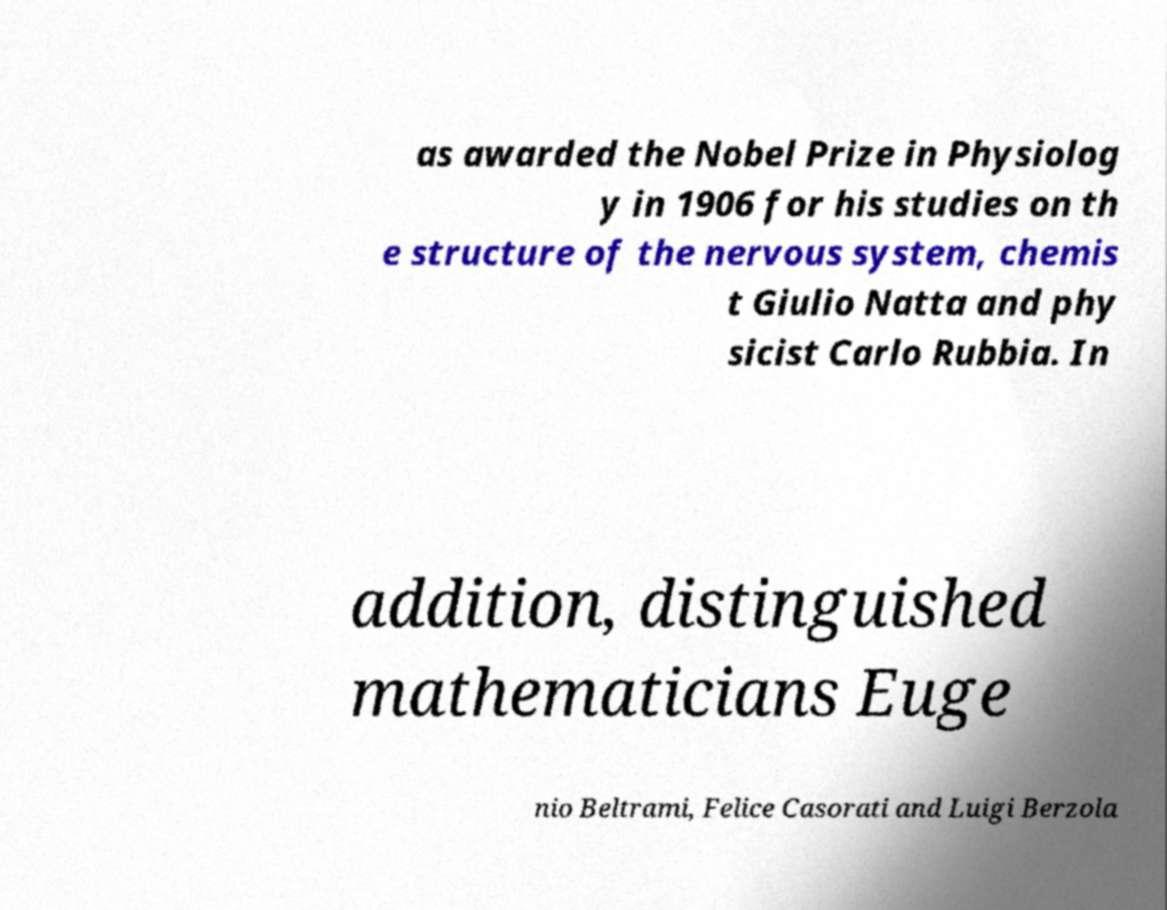Can you read and provide the text displayed in the image?This photo seems to have some interesting text. Can you extract and type it out for me? as awarded the Nobel Prize in Physiolog y in 1906 for his studies on th e structure of the nervous system, chemis t Giulio Natta and phy sicist Carlo Rubbia. In addition, distinguished mathematicians Euge nio Beltrami, Felice Casorati and Luigi Berzola 